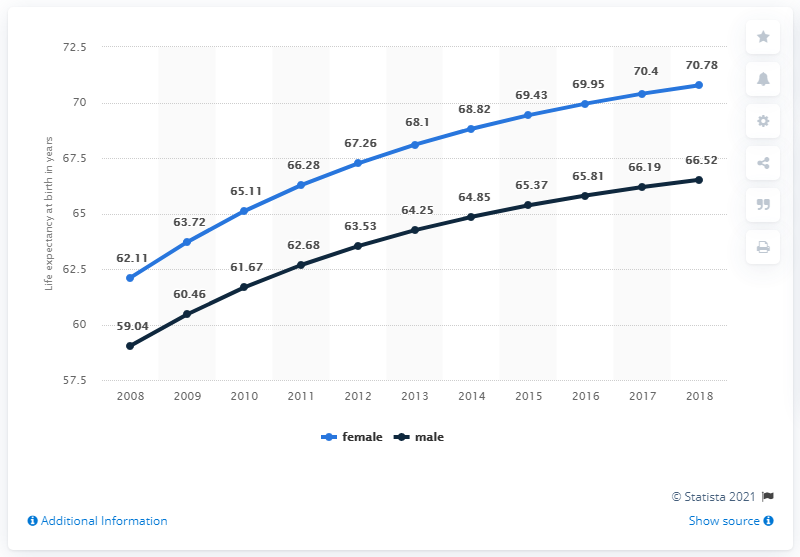Give some essential details in this illustration. In 2018, the difference between male and female was at its maximum. Light blue is the color traditionally associated with female gender. 